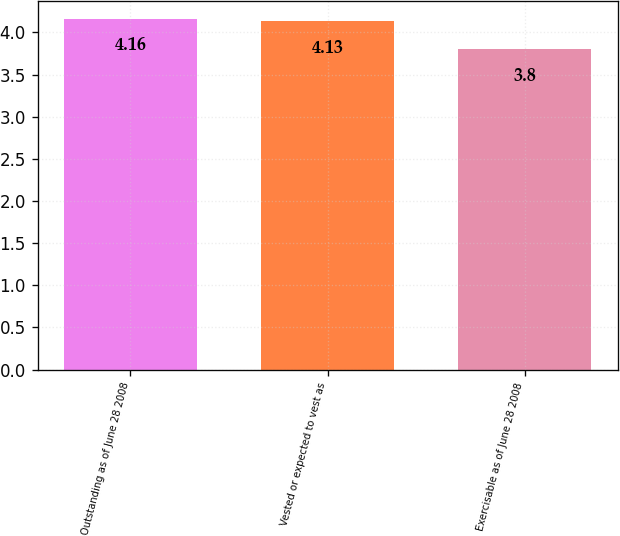<chart> <loc_0><loc_0><loc_500><loc_500><bar_chart><fcel>Outstanding as of June 28 2008<fcel>Vested or expected to vest as<fcel>Exercisable as of June 28 2008<nl><fcel>4.16<fcel>4.13<fcel>3.8<nl></chart> 